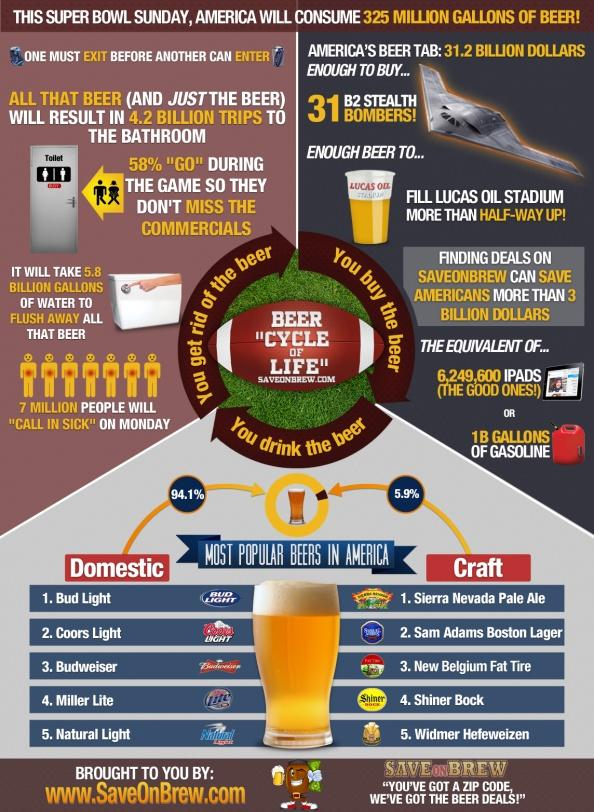Draw attention to some important aspects in this diagram. According to a recent survey, only 5.9% of craft beers in America are used. According to a recent survey, a staggering 94.1% of domestic beers are consumed in America. 